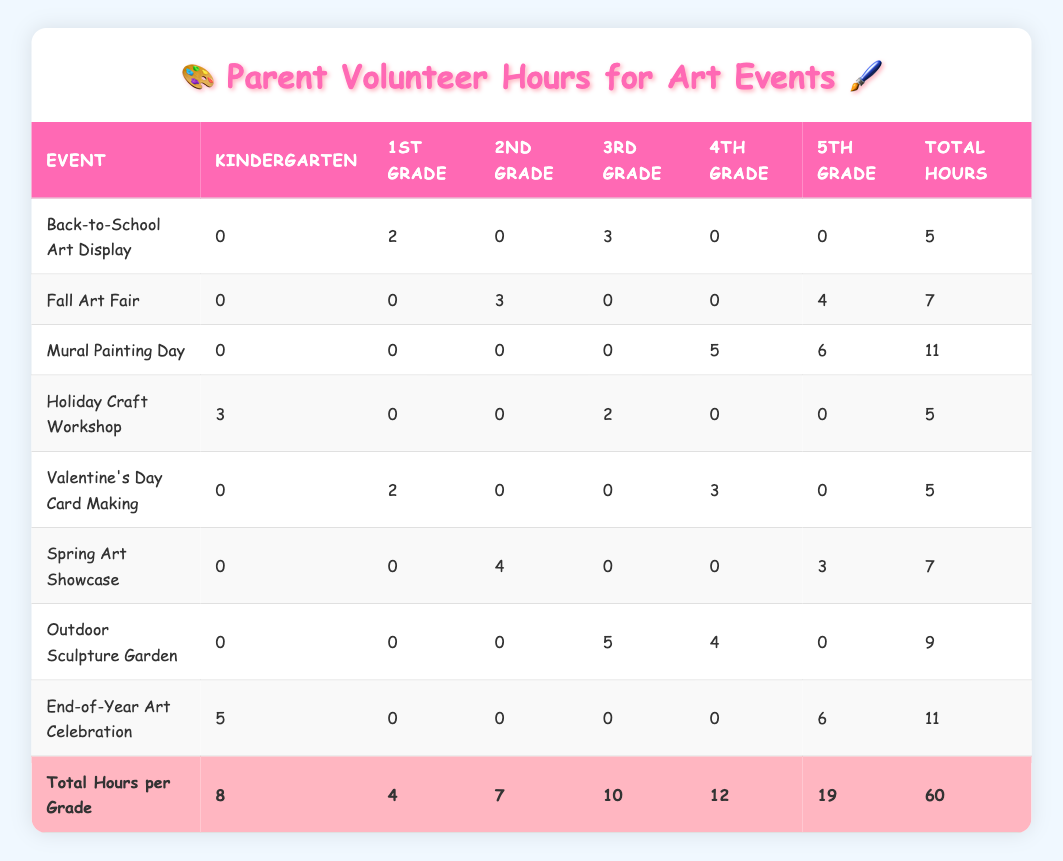What's the total number of hours volunteered for the Fall Art Fair? The Fall Art Fair has two entries: "David Thompson" volunteered 3 hours and "Sarah Rodriguez" volunteered 4 hours. Adding these together gives 3 + 4 = 7 hours.
Answer: 7 How many hours did parents volunteer for the Mural Painting Day? The Mural Painting Day has two parents contributing: "Lisa Patel" volunteered 5 hours and "John Smith" volunteered 6 hours. Adding these, we get 5 + 6 = 11 hours.
Answer: 11 Which event had the highest number of volunteer hours from parents for 5th grade? For 5th grade, the events and their corresponding hours are: Mural Painting Day (6 hours), Fall Art Fair (0 hours), End-of-Year Art Celebration (6 hours). Both Mural Painting Day and End-of-Year Art Celebration have the highest hours at 6 each.
Answer: 6 Did any parents volunteer for 2nd grade during the Back-to-School Art Display? In the Back-to-School Art Display, there are no entries listed for 2nd grade, therefore no parents volunteered for that grade.
Answer: No Calculate the average number of hours volunteered for 3rd grade events. For 3rd grade, the total hours volunteered are: Back-to-School Art Display (3 hours), Holiday Craft Workshop (2 hours), and Outdoor Sculpture Garden (5 hours). Therefore, the sum is 3 + 2 + 5 = 10 hours. There are 3 events contributing, so the average is 10 / 3 ≈ 3.33 hours.
Answer: 3.33 How many parents assisted with the Holiday Craft Workshop? The Holiday Craft Workshop has two entries: "Amanda Lee" and "Robert Garcia". Therefore, a total of 2 parents assisted with this event.
Answer: 2 Which event had the least hours volunteered overall? Reviewing the events: Back-to-School Art Display (5 hours), Fall Art Fair (7 hours), Mural Painting Day (11 hours), Holiday Craft Workshop (5 hours), Valentine's Day Card Making (5 hours), Spring Art Showcase (7 hours), Outdoor Sculpture Garden (9 hours), End-of-Year Art Celebration (11 hours). The events with the least hours volunteered (5 hours) are Back-to-School Art Display, Holiday Craft Workshop, and Valentine's Day Card Making.
Answer: 5 What is the total number of hours volunteered by parents for Kindergarten events? The only event for Kindergarten is the Holiday Craft Workshop (3 hours) and End-of-Year Art Celebration (5 hours). So, the total hours are 3 + 5 = 8.
Answer: 8 